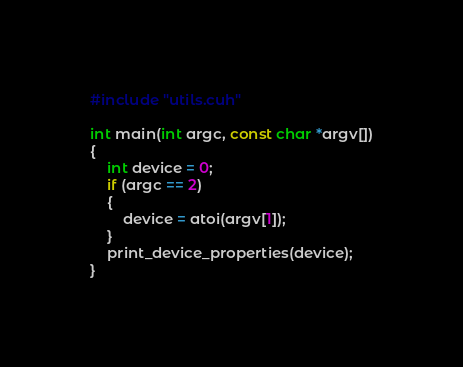Convert code to text. <code><loc_0><loc_0><loc_500><loc_500><_Cuda_>#include "utils.cuh"

int main(int argc, const char *argv[])
{
    int device = 0;
    if (argc == 2)
    {
        device = atoi(argv[1]);
    }
    print_device_properties(device);
}</code> 